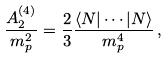Convert formula to latex. <formula><loc_0><loc_0><loc_500><loc_500>\frac { A ^ { ( 4 ) } _ { 2 } } { m _ { p } ^ { 2 } } = \frac { 2 } { 3 } \frac { \langle N | \cdots | N \rangle } { m _ { p } ^ { 4 } } \, ,</formula> 